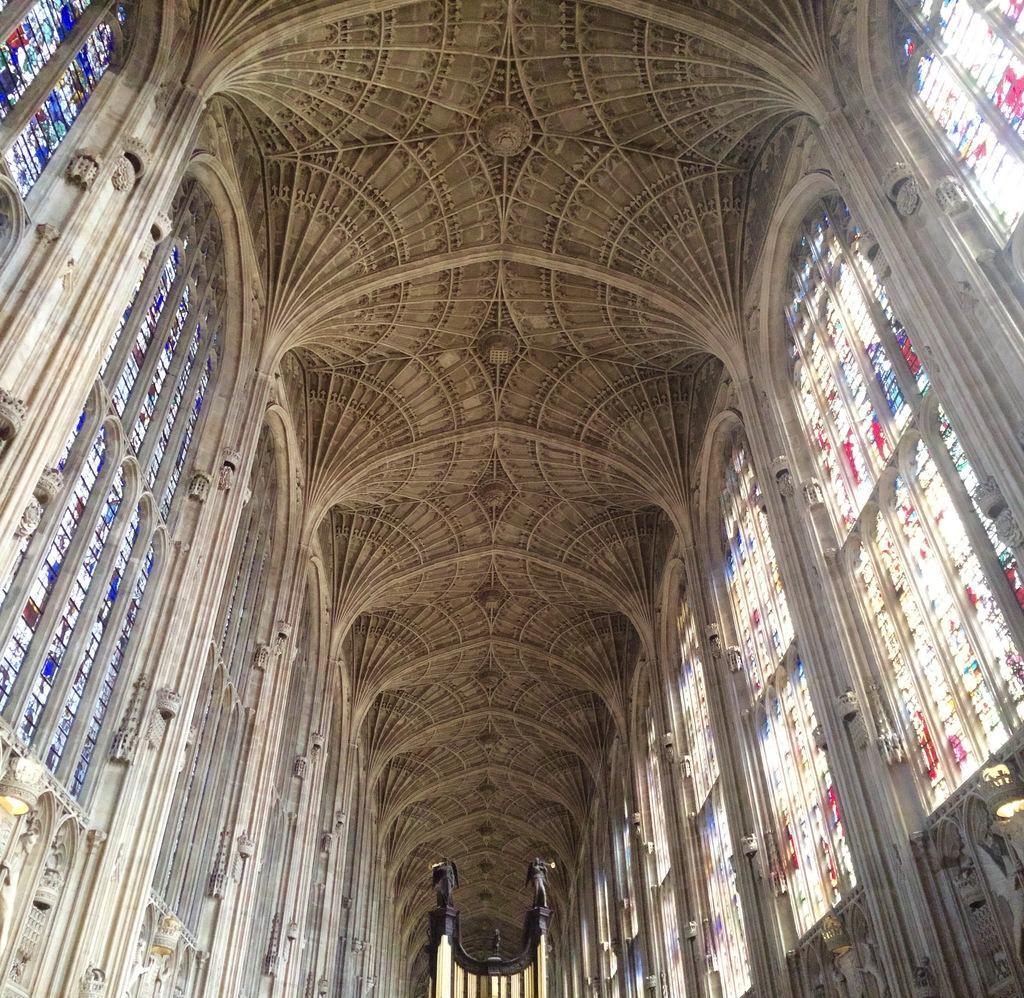Can you describe this image briefly? This image is clicked inside a room. On the either sides of the image there are walls. There are glass windows on the walls. There are prints of a few people and a few objects on the windows. At the bottom there are sculptures on a pillar. At the top there is a ceiling. 